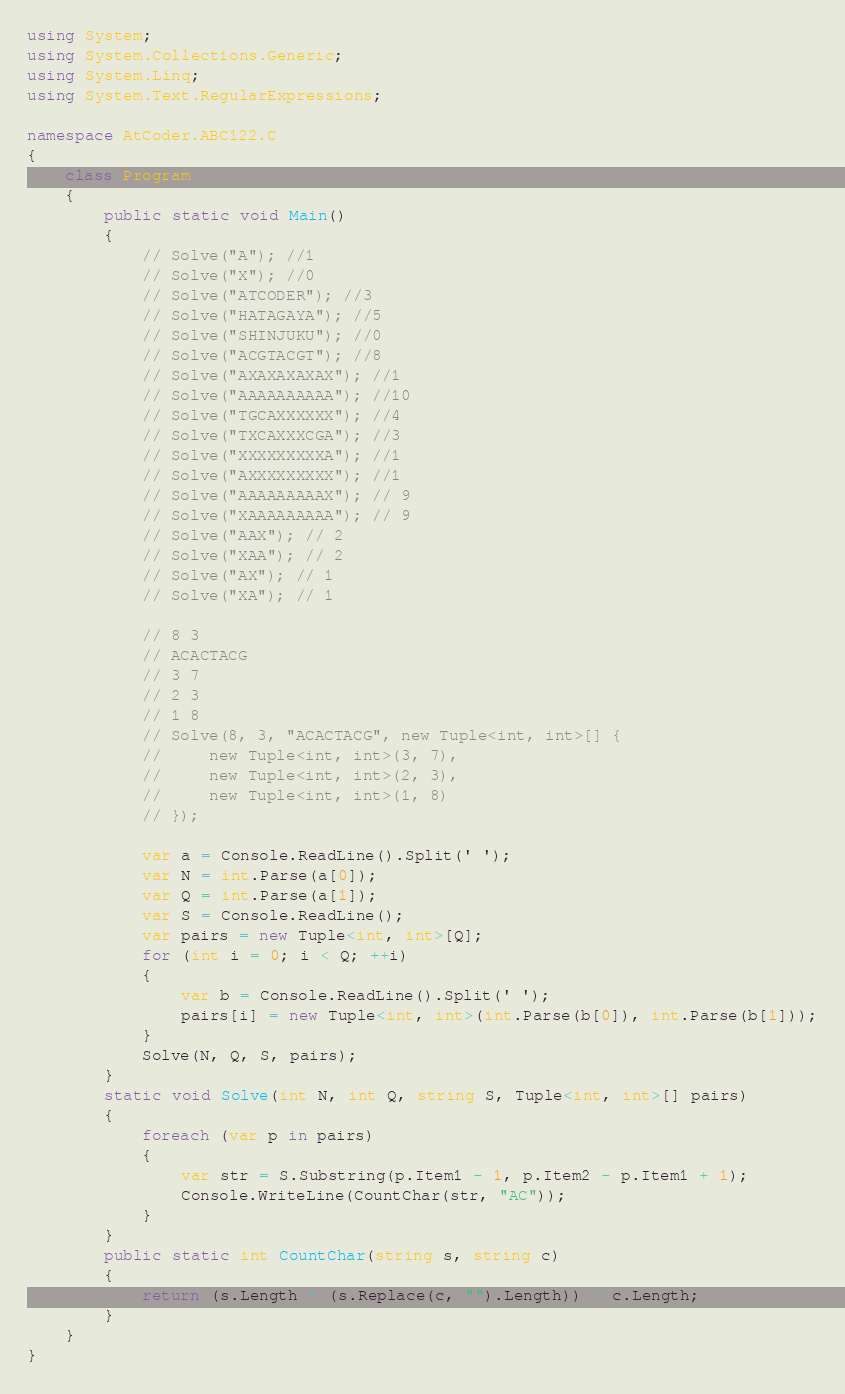<code> <loc_0><loc_0><loc_500><loc_500><_C#_>using System;
using System.Collections.Generic;
using System.Linq;
using System.Text.RegularExpressions;

namespace AtCoder.ABC122.C
{
    class Program
    {
        public static void Main()
        {
            // Solve("A"); //1
            // Solve("X"); //0
            // Solve("ATCODER"); //3
            // Solve("HATAGAYA"); //5
            // Solve("SHINJUKU"); //0
            // Solve("ACGTACGT"); //8
            // Solve("AXAXAXAXAX"); //1
            // Solve("AAAAAAAAAA"); //10
            // Solve("TGCAXXXXXX"); //4
            // Solve("TXCAXXXCGA"); //3
            // Solve("XXXXXXXXXA"); //1
            // Solve("AXXXXXXXXX"); //1
            // Solve("AAAAAAAAAX"); // 9 
            // Solve("XAAAAAAAAA"); // 9
            // Solve("AAX"); // 2
            // Solve("XAA"); // 2
            // Solve("AX"); // 1
            // Solve("XA"); // 1

            // 8 3
            // ACACTACG
            // 3 7
            // 2 3
            // 1 8
            // Solve(8, 3, "ACACTACG", new Tuple<int, int>[] {
            //     new Tuple<int, int>(3, 7),
            //     new Tuple<int, int>(2, 3),
            //     new Tuple<int, int>(1, 8)
            // });

            var a = Console.ReadLine().Split(' ');
            var N = int.Parse(a[0]);
            var Q = int.Parse(a[1]);
            var S = Console.ReadLine();
            var pairs = new Tuple<int, int>[Q];
            for (int i = 0; i < Q; ++i)
            {
                var b = Console.ReadLine().Split(' ');
                pairs[i] = new Tuple<int, int>(int.Parse(b[0]), int.Parse(b[1]));
            }
            Solve(N, Q, S, pairs);
        }
        static void Solve(int N, int Q, string S, Tuple<int, int>[] pairs)
        {
            foreach (var p in pairs)
            {
                var str = S.Substring(p.Item1 - 1, p.Item2 - p.Item1 + 1);
                Console.WriteLine(CountChar(str, "AC"));
            }
        }
        public static int CountChar(string s, string c)
        {
            return (s.Length - (s.Replace(c, "").Length)) / c.Length;
        }
    }
}

</code> 